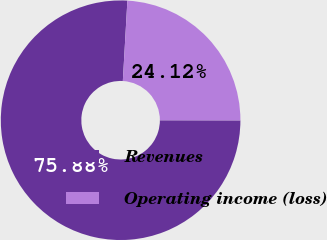Convert chart to OTSL. <chart><loc_0><loc_0><loc_500><loc_500><pie_chart><fcel>Revenues<fcel>Operating income (loss)<nl><fcel>75.88%<fcel>24.12%<nl></chart> 